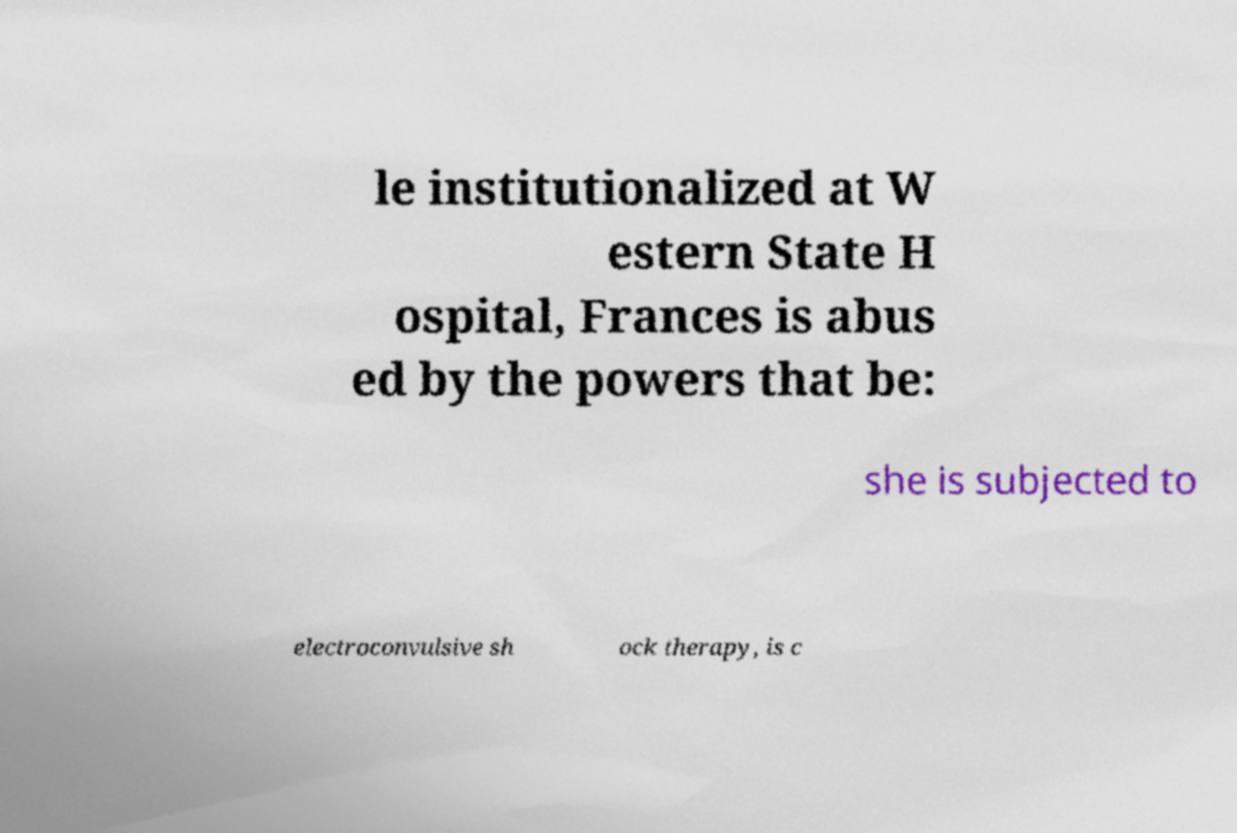There's text embedded in this image that I need extracted. Can you transcribe it verbatim? le institutionalized at W estern State H ospital, Frances is abus ed by the powers that be: she is subjected to electroconvulsive sh ock therapy, is c 